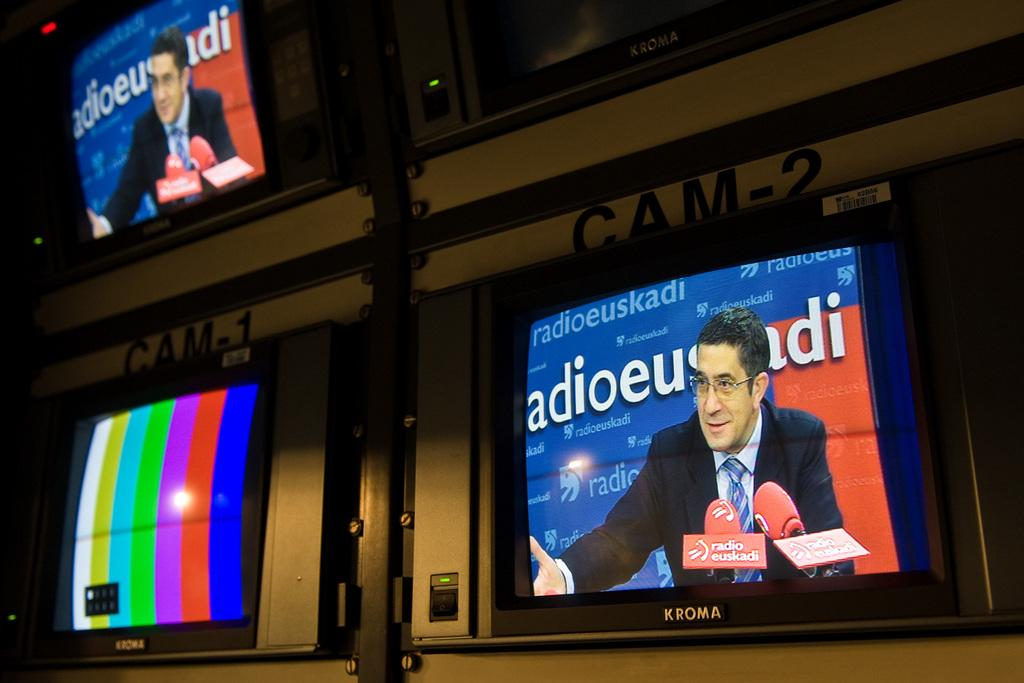<image>
Render a clear and concise summary of the photo. a screen that has the letters adio on it 